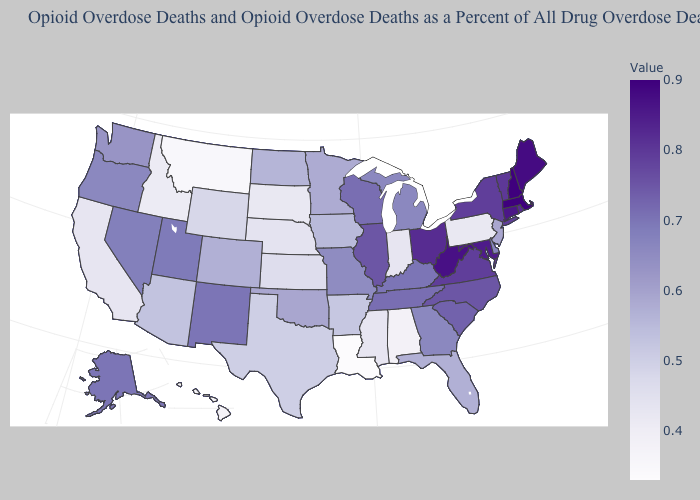Which states have the lowest value in the USA?
Write a very short answer. Louisiana. Is the legend a continuous bar?
Write a very short answer. Yes. 